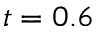<formula> <loc_0><loc_0><loc_500><loc_500>t = 0 . 6</formula> 